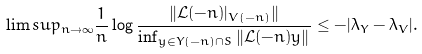<formula> <loc_0><loc_0><loc_500><loc_500>\lim s u p _ { n \to \infty } \frac { 1 } { n } \log \frac { \| \mathcal { L } ( - n ) | _ { V ( - n ) } \| } { \inf _ { y \in Y ( - n ) \cap S } \| \mathcal { L } ( - n ) y \| } \leq - | \lambda _ { Y } - \lambda _ { V } | .</formula> 